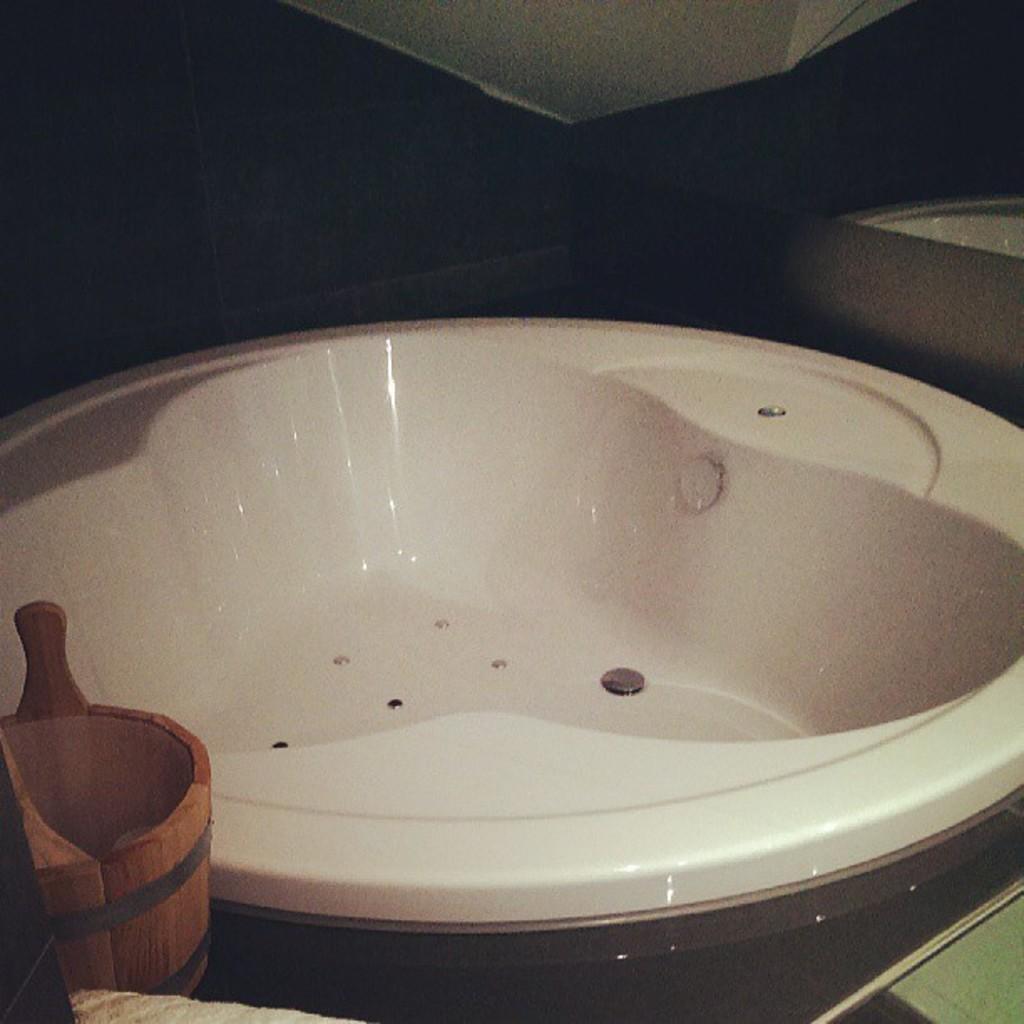Could you give a brief overview of what you see in this image? In the foreground of this image, there is a wooden object, two objects at the bottom and a white color object in the middle. The top side of the image is not clear. 